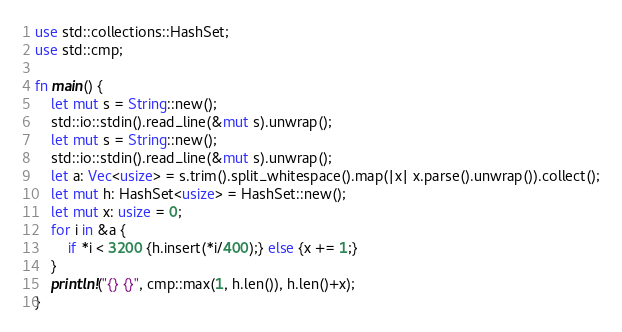<code> <loc_0><loc_0><loc_500><loc_500><_Rust_>use std::collections::HashSet;
use std::cmp;

fn main() {
    let mut s = String::new();
    std::io::stdin().read_line(&mut s).unwrap();
    let mut s = String::new();
    std::io::stdin().read_line(&mut s).unwrap();
    let a: Vec<usize> = s.trim().split_whitespace().map(|x| x.parse().unwrap()).collect();
    let mut h: HashSet<usize> = HashSet::new();
    let mut x: usize = 0;
    for i in &a {
        if *i < 3200 {h.insert(*i/400);} else {x += 1;}
    }
    println!("{} {}", cmp::max(1, h.len()), h.len()+x);
}

</code> 